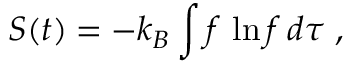Convert formula to latex. <formula><loc_0><loc_0><loc_500><loc_500>S ( t ) = - k _ { B } \int f \, \ln f \, d \tau \, ,</formula> 